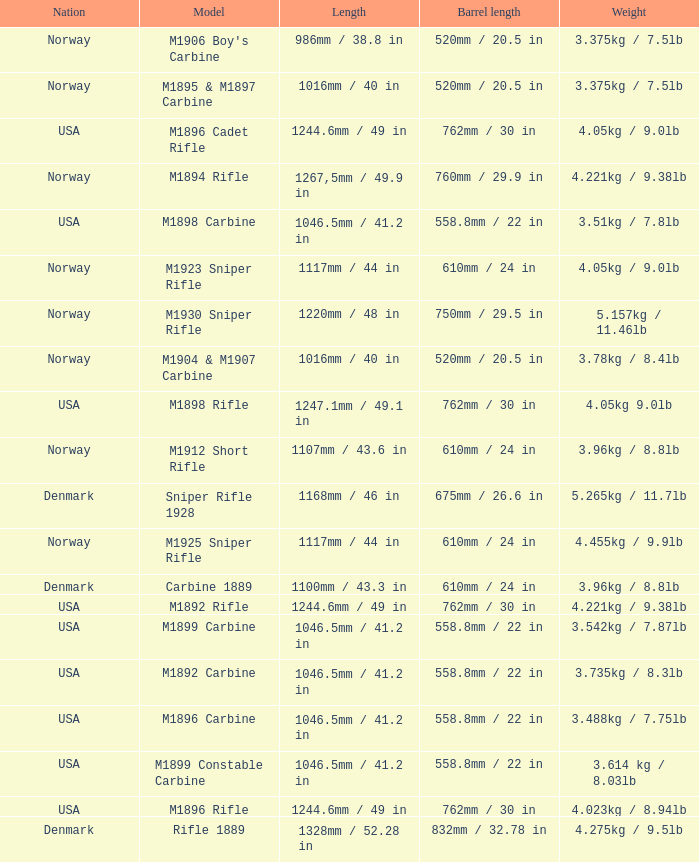What is Nation, when Model is M1895 & M1897 Carbine? Norway. Can you parse all the data within this table? {'header': ['Nation', 'Model', 'Length', 'Barrel length', 'Weight'], 'rows': [['Norway', "M1906 Boy's Carbine", '986mm / 38.8 in', '520mm / 20.5 in', '3.375kg / 7.5lb'], ['Norway', 'M1895 & M1897 Carbine', '1016mm / 40 in', '520mm / 20.5 in', '3.375kg / 7.5lb'], ['USA', 'M1896 Cadet Rifle', '1244.6mm / 49 in', '762mm / 30 in', '4.05kg / 9.0lb'], ['Norway', 'M1894 Rifle', '1267,5mm / 49.9 in', '760mm / 29.9 in', '4.221kg / 9.38lb'], ['USA', 'M1898 Carbine', '1046.5mm / 41.2 in', '558.8mm / 22 in', '3.51kg / 7.8lb'], ['Norway', 'M1923 Sniper Rifle', '1117mm / 44 in', '610mm / 24 in', '4.05kg / 9.0lb'], ['Norway', 'M1930 Sniper Rifle', '1220mm / 48 in', '750mm / 29.5 in', '5.157kg / 11.46lb'], ['Norway', 'M1904 & M1907 Carbine', '1016mm / 40 in', '520mm / 20.5 in', '3.78kg / 8.4lb'], ['USA', 'M1898 Rifle', '1247.1mm / 49.1 in', '762mm / 30 in', '4.05kg 9.0lb'], ['Norway', 'M1912 Short Rifle', '1107mm / 43.6 in', '610mm / 24 in', '3.96kg / 8.8lb'], ['Denmark', 'Sniper Rifle 1928', '1168mm / 46 in', '675mm / 26.6 in', '5.265kg / 11.7lb'], ['Norway', 'M1925 Sniper Rifle', '1117mm / 44 in', '610mm / 24 in', '4.455kg / 9.9lb'], ['Denmark', 'Carbine 1889', '1100mm / 43.3 in', '610mm / 24 in', '3.96kg / 8.8lb'], ['USA', 'M1892 Rifle', '1244.6mm / 49 in', '762mm / 30 in', '4.221kg / 9.38lb'], ['USA', 'M1899 Carbine', '1046.5mm / 41.2 in', '558.8mm / 22 in', '3.542kg / 7.87lb'], ['USA', 'M1892 Carbine', '1046.5mm / 41.2 in', '558.8mm / 22 in', '3.735kg / 8.3lb'], ['USA', 'M1896 Carbine', '1046.5mm / 41.2 in', '558.8mm / 22 in', '3.488kg / 7.75lb'], ['USA', 'M1899 Constable Carbine', '1046.5mm / 41.2 in', '558.8mm / 22 in', '3.614 kg / 8.03lb'], ['USA', 'M1896 Rifle', '1244.6mm / 49 in', '762mm / 30 in', '4.023kg / 8.94lb'], ['Denmark', 'Rifle 1889', '1328mm / 52.28 in', '832mm / 32.78 in', '4.275kg / 9.5lb']]} 